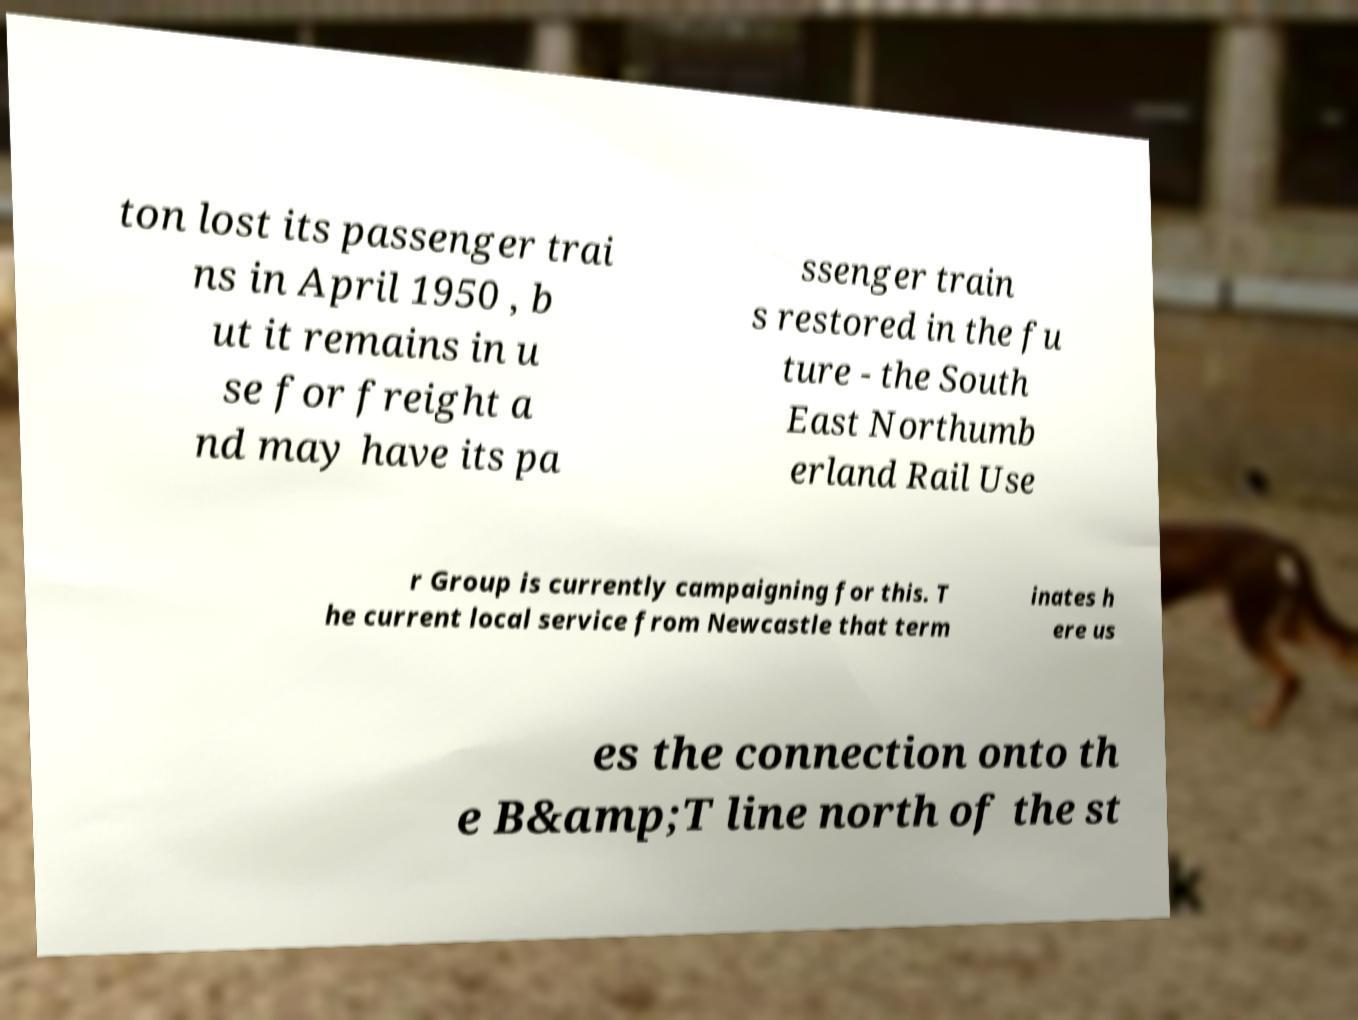Please identify and transcribe the text found in this image. ton lost its passenger trai ns in April 1950 , b ut it remains in u se for freight a nd may have its pa ssenger train s restored in the fu ture - the South East Northumb erland Rail Use r Group is currently campaigning for this. T he current local service from Newcastle that term inates h ere us es the connection onto th e B&amp;T line north of the st 